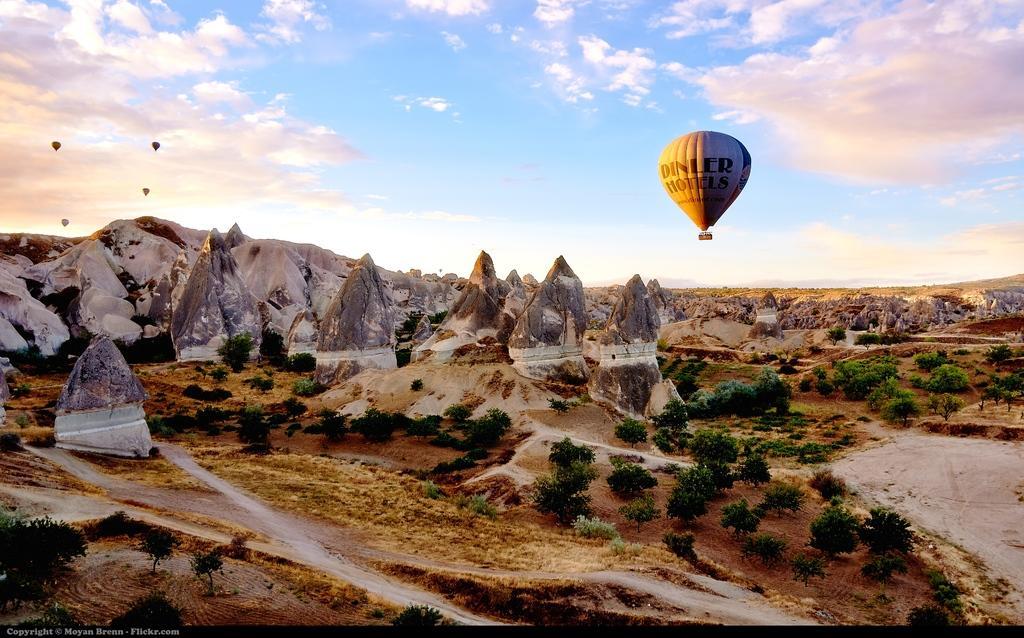Can you describe this image briefly? This is completely an outdoor picture. In this picture we can see a clear blue sky with clouds and we can see few parachutes. On the background of the picture we can see hills. These are the mountain peaks and in front of the picture there are few bushes. 